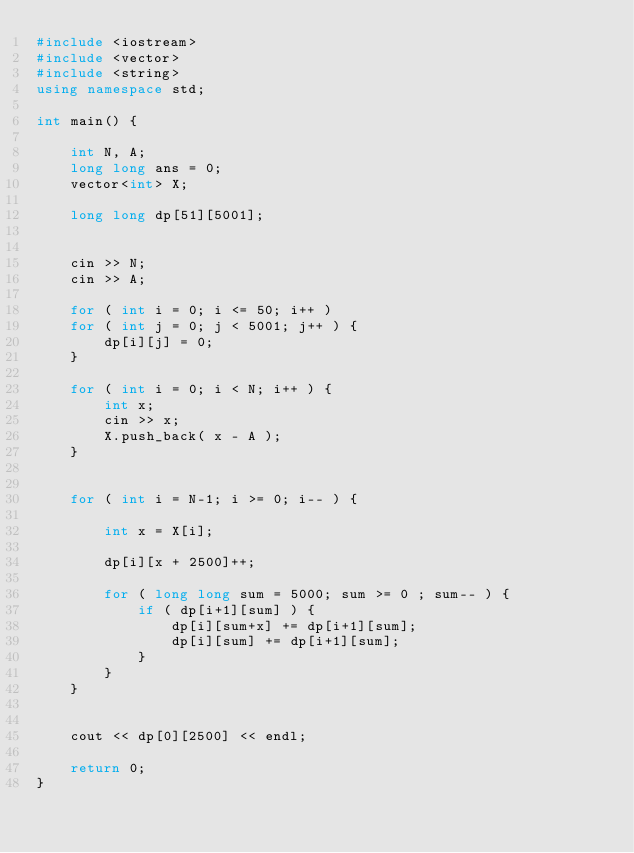Convert code to text. <code><loc_0><loc_0><loc_500><loc_500><_C++_>#include <iostream>
#include <vector>
#include <string>
using namespace std;

int main() {
    
    int N, A;
    long long ans = 0;
    vector<int> X;
    
    long long dp[51][5001];
    
    
    cin >> N;
    cin >> A;
    
    for ( int i = 0; i <= 50; i++ )
    for ( int j = 0; j < 5001; j++ ) {
        dp[i][j] = 0;
    }
    
    for ( int i = 0; i < N; i++ ) {
        int x;
        cin >> x;
        X.push_back( x - A );
    }
    
    
    for ( int i = N-1; i >= 0; i-- ) {
        
        int x = X[i];
        
        dp[i][x + 2500]++;
        
        for ( long long sum = 5000; sum >= 0 ; sum-- ) {
            if ( dp[i+1][sum] ) {
                dp[i][sum+x] += dp[i+1][sum];
                dp[i][sum] += dp[i+1][sum];
            }
        }
    }
    
    
    cout << dp[0][2500] << endl;
    
    return 0;
}</code> 